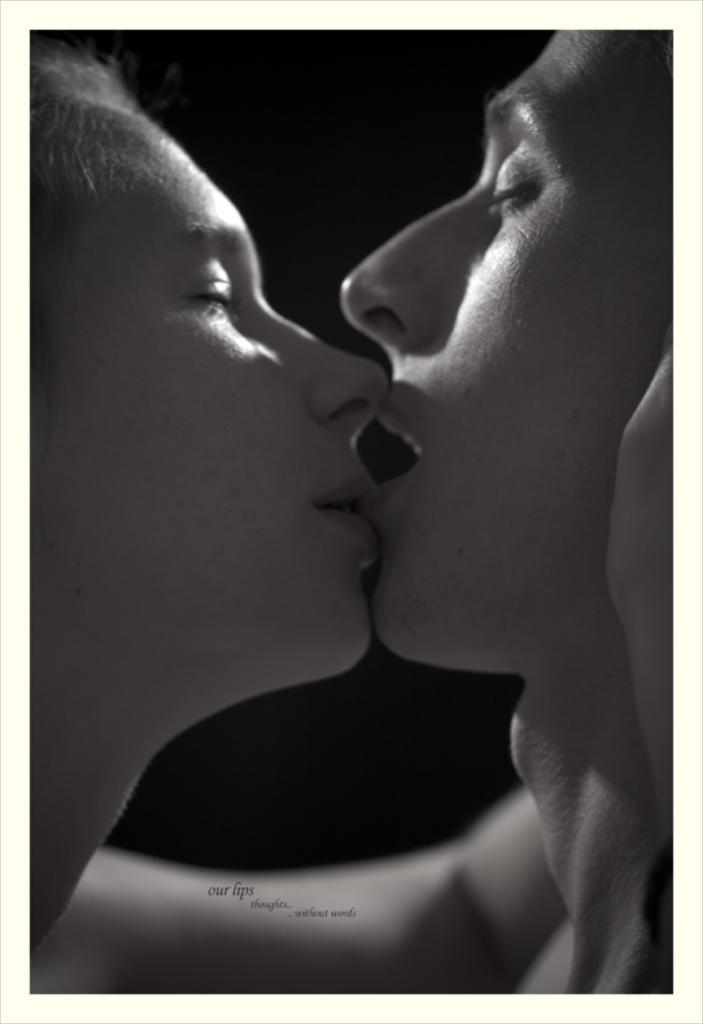How would you summarize this image in a sentence or two? In this image I can see two people and there is a black background. 